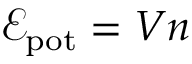Convert formula to latex. <formula><loc_0><loc_0><loc_500><loc_500>\mathcal { E } _ { p o t } = V n</formula> 